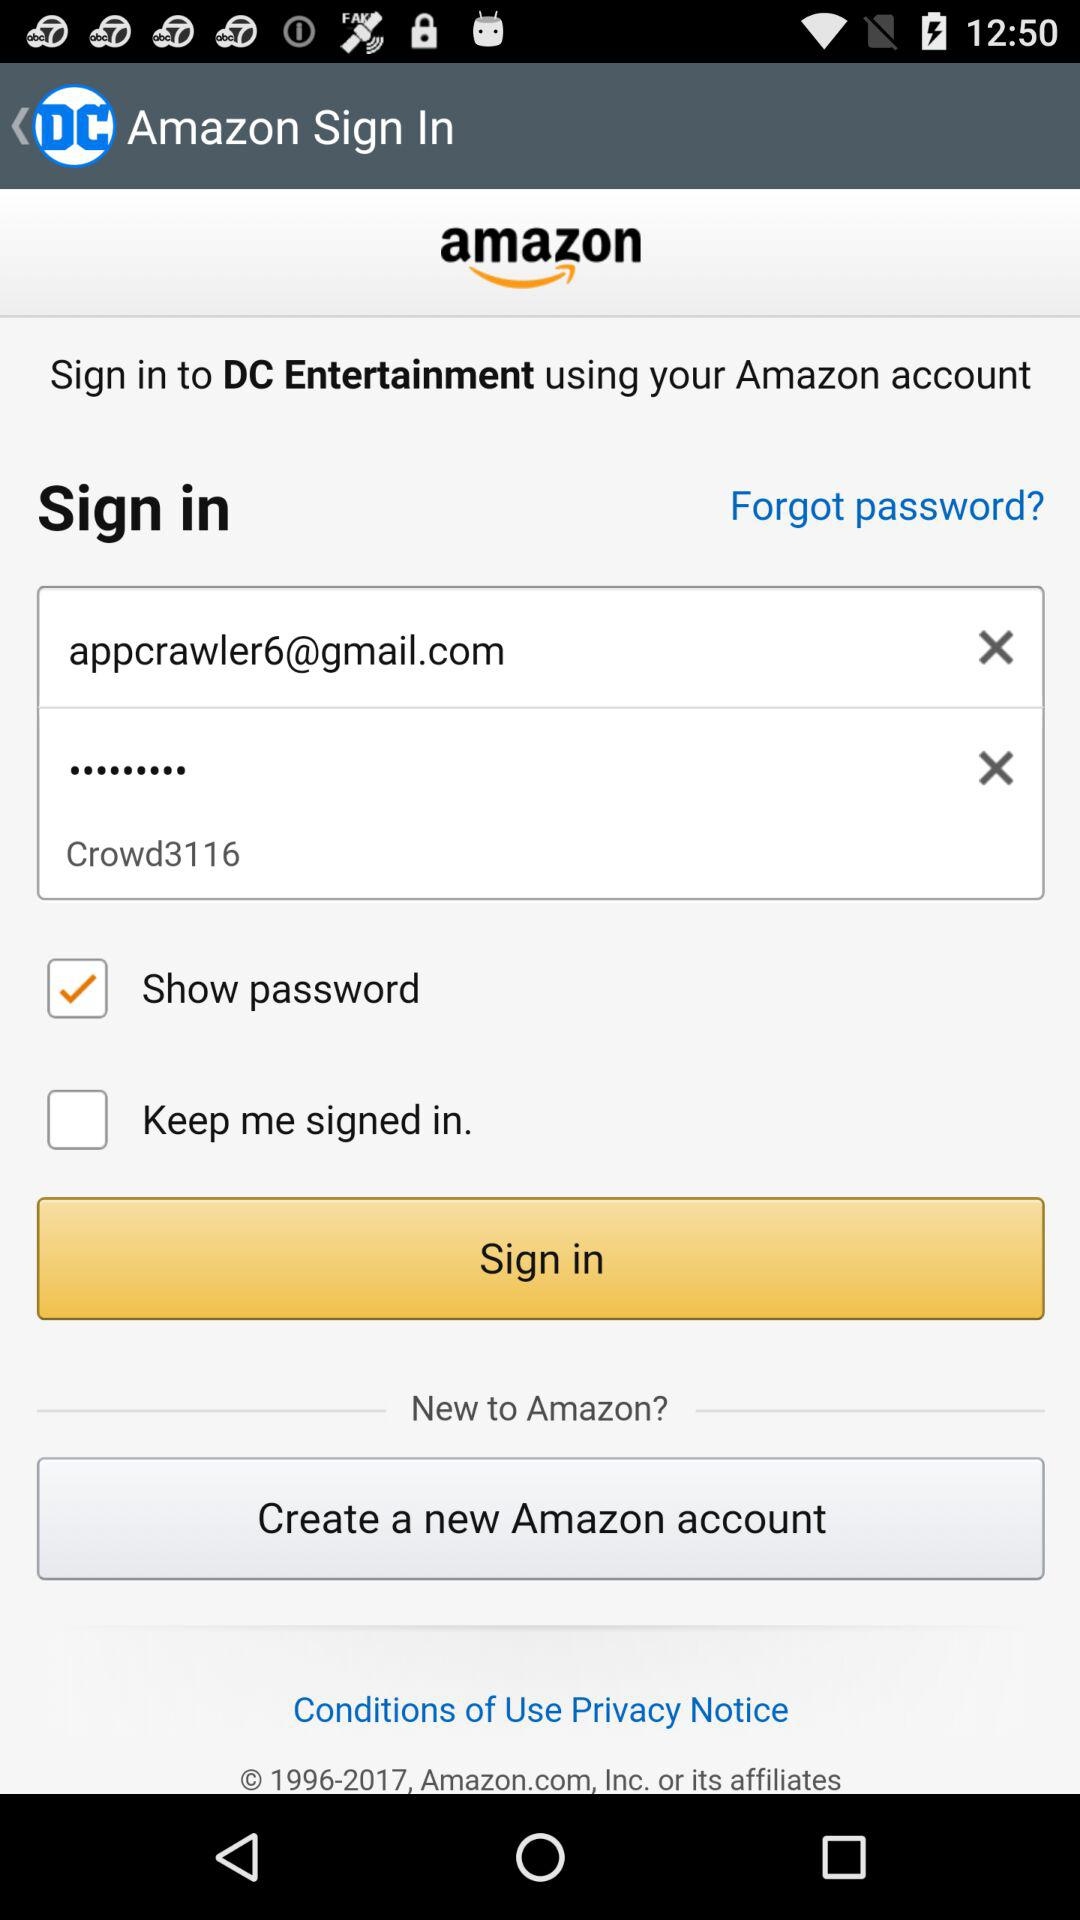What is a password? The password is "Crowd3116". 